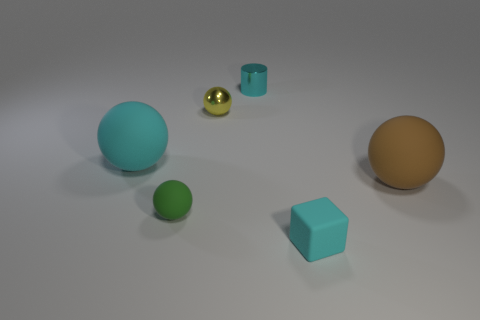The large rubber thing that is the same color as the tiny cylinder is what shape?
Give a very brief answer. Sphere. Do the big ball that is to the left of the cyan cylinder and the small yellow sphere have the same material?
Offer a terse response. No. Are there an equal number of tiny cylinders on the right side of the cyan rubber cube and small cyan metallic objects that are on the left side of the small cylinder?
Provide a short and direct response. Yes. There is a metal object that is in front of the thing behind the yellow shiny sphere; what size is it?
Provide a succinct answer. Small. What is the cyan thing that is both in front of the small metal cylinder and behind the cyan block made of?
Keep it short and to the point. Rubber. What number of other objects are there of the same size as the yellow sphere?
Keep it short and to the point. 3. The rubber block is what color?
Your answer should be compact. Cyan. There is a big object that is right of the block; does it have the same color as the tiny object behind the small yellow ball?
Give a very brief answer. No. What is the size of the yellow sphere?
Keep it short and to the point. Small. How big is the cyan object behind the large cyan object?
Provide a succinct answer. Small. 